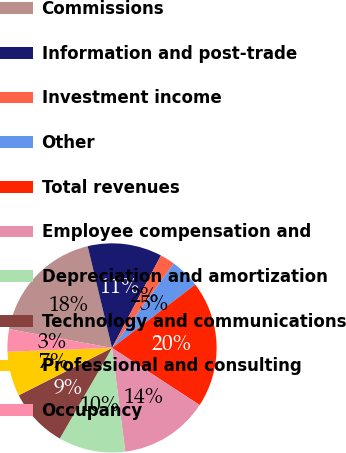<chart> <loc_0><loc_0><loc_500><loc_500><pie_chart><fcel>Commissions<fcel>Information and post-trade<fcel>Investment income<fcel>Other<fcel>Total revenues<fcel>Employee compensation and<fcel>Depreciation and amortization<fcel>Technology and communications<fcel>Professional and consulting<fcel>Occupancy<nl><fcel>18.39%<fcel>11.49%<fcel>2.3%<fcel>4.6%<fcel>19.54%<fcel>13.79%<fcel>10.34%<fcel>9.2%<fcel>6.9%<fcel>3.45%<nl></chart> 